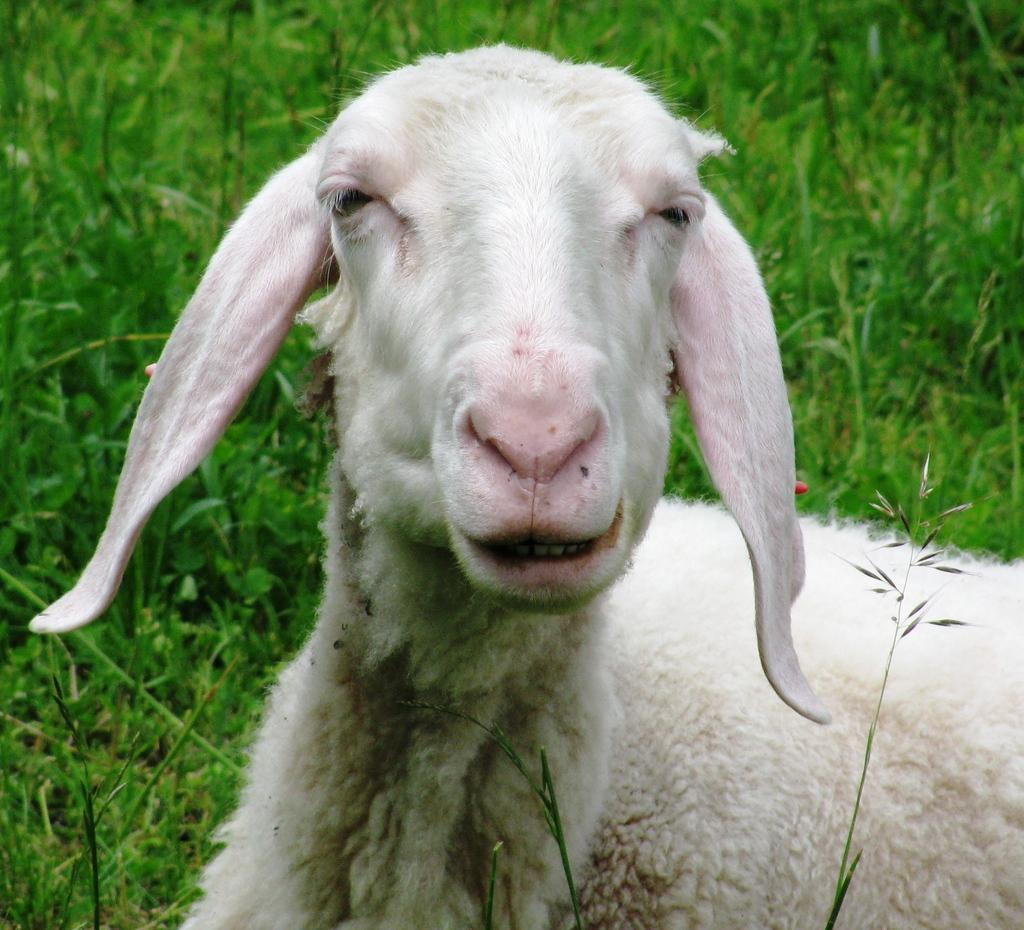What animal is the main subject of the image? There is a white goat in the image. Where is the goat located in the image? The goat is in the middle of the image. What type of vegetation can be seen in the background of the image? There is grass in the background of the image. Can you tell me how the goat is touching the meat in the image? There is no meat present in the image, and therefore no such interaction can be observed. 